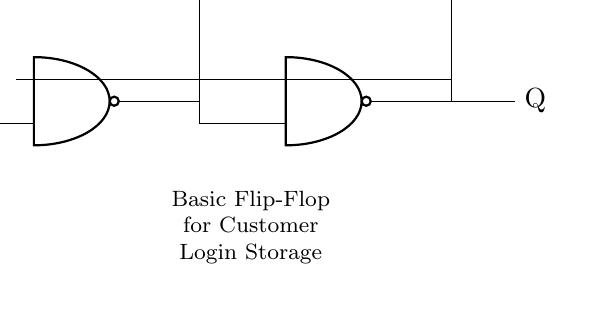What type of circuit is this? This circuit is a flip-flop, which is a basic memory element in digital electronics. It stores binary information and can hold its state.
Answer: flip-flop How many NAND gates are in this circuit? The circuit consists of four NAND gates, which are arranged to form the flip-flop. Each NAND gate is labeled in the drawing.
Answer: four What are the output labels of the flip-flop? The outputs of the flip-flop are labeled as Q and not Q, which represent the stored binary state and its complement, respectively.
Answer: Q and not Q What is the function of the Set and Reset inputs? The Set input is used to store a high state in the flip-flop, while the Reset input clears it, returning it to a low state. These inputs control the behavior of the stored information.
Answer: Set and Reset What happens when both Set and Reset inputs are activated? Activating both inputs at the same time leads to an undefined state for the flip-flop, where the outputs may not be predictable. It is typically avoided in practical applications.
Answer: undefined state What is the significance of the connections between the NAND gates? The interconnections form a feedback loop necessary for the flip-flop's functionality, enabling it to maintain its state until changed by the Set or Reset inputs.
Answer: feedback loop 